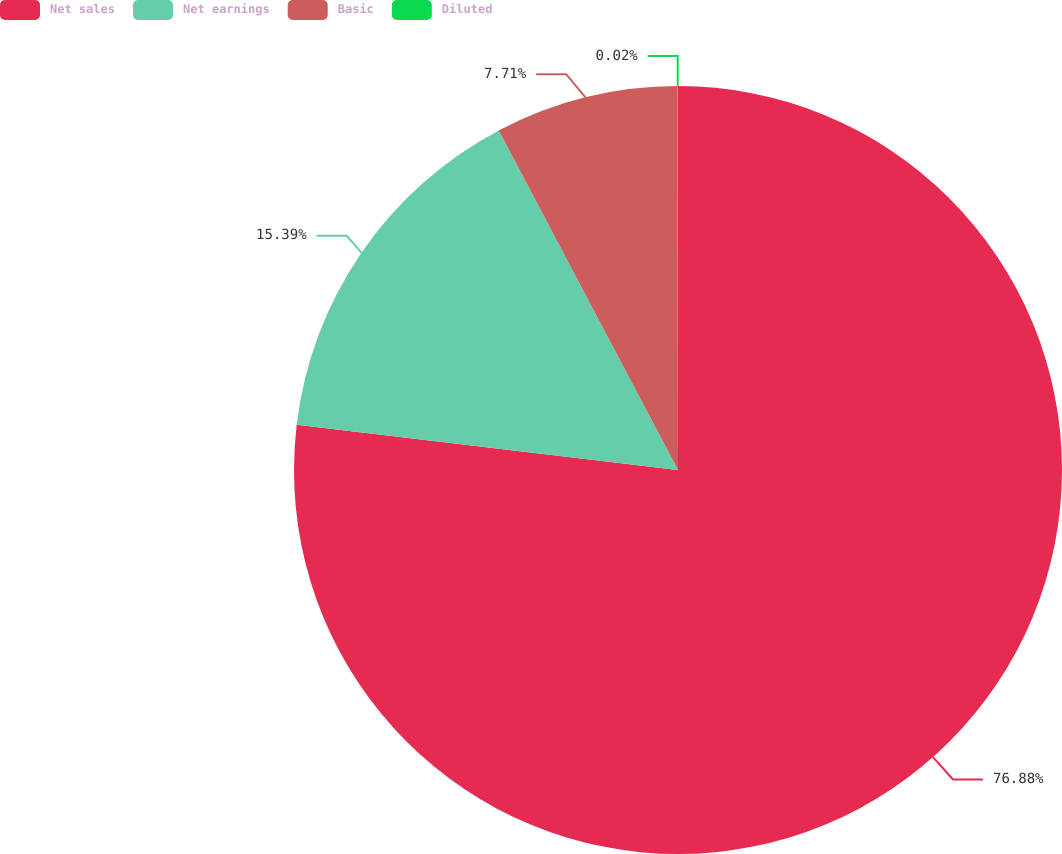Convert chart. <chart><loc_0><loc_0><loc_500><loc_500><pie_chart><fcel>Net sales<fcel>Net earnings<fcel>Basic<fcel>Diluted<nl><fcel>76.88%<fcel>15.39%<fcel>7.71%<fcel>0.02%<nl></chart> 